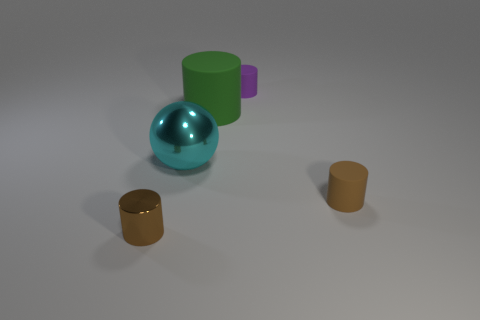Subtract all small cylinders. How many cylinders are left? 1 Add 1 small objects. How many objects exist? 6 Subtract all green cylinders. How many cylinders are left? 3 Subtract 2 cylinders. How many cylinders are left? 2 Subtract all brown blocks. How many brown cylinders are left? 2 Subtract all cylinders. How many objects are left? 1 Subtract all gray cylinders. Subtract all yellow blocks. How many cylinders are left? 4 Subtract all large green things. Subtract all tiny rubber cylinders. How many objects are left? 2 Add 4 large cyan shiny things. How many large cyan shiny things are left? 5 Add 4 small green rubber cubes. How many small green rubber cubes exist? 4 